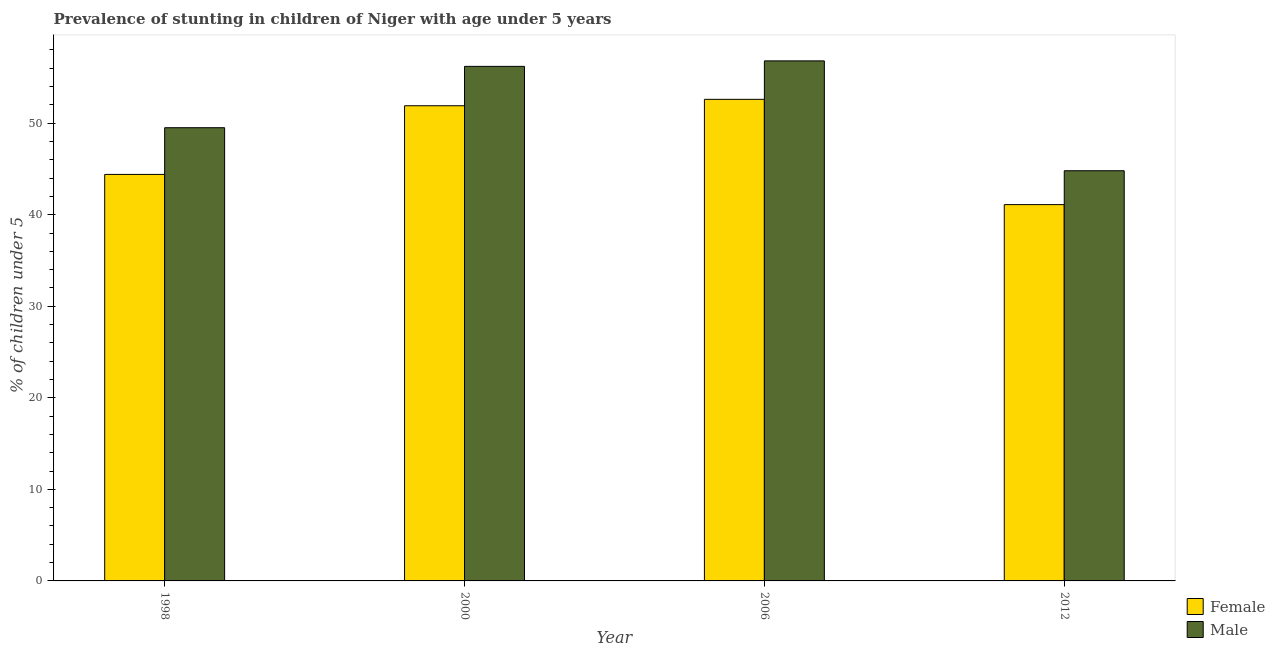How many different coloured bars are there?
Your response must be concise. 2. How many groups of bars are there?
Offer a very short reply. 4. How many bars are there on the 2nd tick from the left?
Your answer should be very brief. 2. What is the label of the 1st group of bars from the left?
Your response must be concise. 1998. What is the percentage of stunted female children in 2000?
Give a very brief answer. 51.9. Across all years, what is the maximum percentage of stunted female children?
Keep it short and to the point. 52.6. Across all years, what is the minimum percentage of stunted male children?
Your answer should be very brief. 44.8. In which year was the percentage of stunted male children maximum?
Your answer should be very brief. 2006. What is the total percentage of stunted female children in the graph?
Offer a very short reply. 190. What is the difference between the percentage of stunted male children in 2000 and that in 2012?
Provide a short and direct response. 11.4. What is the difference between the percentage of stunted female children in 2012 and the percentage of stunted male children in 1998?
Your answer should be compact. -3.3. What is the average percentage of stunted female children per year?
Your response must be concise. 47.5. In the year 2012, what is the difference between the percentage of stunted female children and percentage of stunted male children?
Offer a terse response. 0. What is the ratio of the percentage of stunted female children in 2006 to that in 2012?
Make the answer very short. 1.28. What is the difference between the highest and the second highest percentage of stunted female children?
Offer a very short reply. 0.7. Is the sum of the percentage of stunted male children in 2000 and 2006 greater than the maximum percentage of stunted female children across all years?
Make the answer very short. Yes. What does the 2nd bar from the left in 2000 represents?
Give a very brief answer. Male. What does the 2nd bar from the right in 2000 represents?
Your response must be concise. Female. How many bars are there?
Your response must be concise. 8. What is the difference between two consecutive major ticks on the Y-axis?
Provide a succinct answer. 10. Does the graph contain grids?
Give a very brief answer. No. Where does the legend appear in the graph?
Offer a very short reply. Bottom right. How many legend labels are there?
Provide a succinct answer. 2. What is the title of the graph?
Give a very brief answer. Prevalence of stunting in children of Niger with age under 5 years. What is the label or title of the Y-axis?
Your response must be concise.  % of children under 5. What is the  % of children under 5 in Female in 1998?
Provide a succinct answer. 44.4. What is the  % of children under 5 in Male in 1998?
Make the answer very short. 49.5. What is the  % of children under 5 in Female in 2000?
Provide a short and direct response. 51.9. What is the  % of children under 5 of Male in 2000?
Your answer should be compact. 56.2. What is the  % of children under 5 of Female in 2006?
Provide a succinct answer. 52.6. What is the  % of children under 5 in Male in 2006?
Keep it short and to the point. 56.8. What is the  % of children under 5 of Female in 2012?
Your response must be concise. 41.1. What is the  % of children under 5 in Male in 2012?
Offer a terse response. 44.8. Across all years, what is the maximum  % of children under 5 in Female?
Keep it short and to the point. 52.6. Across all years, what is the maximum  % of children under 5 in Male?
Your answer should be very brief. 56.8. Across all years, what is the minimum  % of children under 5 in Female?
Give a very brief answer. 41.1. Across all years, what is the minimum  % of children under 5 of Male?
Offer a very short reply. 44.8. What is the total  % of children under 5 of Female in the graph?
Provide a succinct answer. 190. What is the total  % of children under 5 in Male in the graph?
Provide a succinct answer. 207.3. What is the difference between the  % of children under 5 in Female in 1998 and that in 2006?
Ensure brevity in your answer.  -8.2. What is the difference between the  % of children under 5 in Male in 1998 and that in 2006?
Provide a short and direct response. -7.3. What is the difference between the  % of children under 5 of Male in 1998 and that in 2012?
Ensure brevity in your answer.  4.7. What is the difference between the  % of children under 5 of Male in 2000 and that in 2006?
Keep it short and to the point. -0.6. What is the difference between the  % of children under 5 in Female in 1998 and the  % of children under 5 in Male in 2006?
Give a very brief answer. -12.4. What is the difference between the  % of children under 5 of Female in 2000 and the  % of children under 5 of Male in 2012?
Offer a terse response. 7.1. What is the difference between the  % of children under 5 of Female in 2006 and the  % of children under 5 of Male in 2012?
Give a very brief answer. 7.8. What is the average  % of children under 5 in Female per year?
Your answer should be compact. 47.5. What is the average  % of children under 5 in Male per year?
Make the answer very short. 51.83. In the year 1998, what is the difference between the  % of children under 5 in Female and  % of children under 5 in Male?
Make the answer very short. -5.1. In the year 2000, what is the difference between the  % of children under 5 of Female and  % of children under 5 of Male?
Your answer should be very brief. -4.3. In the year 2006, what is the difference between the  % of children under 5 of Female and  % of children under 5 of Male?
Offer a terse response. -4.2. What is the ratio of the  % of children under 5 in Female in 1998 to that in 2000?
Offer a very short reply. 0.86. What is the ratio of the  % of children under 5 in Male in 1998 to that in 2000?
Provide a short and direct response. 0.88. What is the ratio of the  % of children under 5 of Female in 1998 to that in 2006?
Give a very brief answer. 0.84. What is the ratio of the  % of children under 5 of Male in 1998 to that in 2006?
Make the answer very short. 0.87. What is the ratio of the  % of children under 5 in Female in 1998 to that in 2012?
Make the answer very short. 1.08. What is the ratio of the  % of children under 5 of Male in 1998 to that in 2012?
Provide a short and direct response. 1.1. What is the ratio of the  % of children under 5 in Female in 2000 to that in 2006?
Your answer should be very brief. 0.99. What is the ratio of the  % of children under 5 in Male in 2000 to that in 2006?
Your response must be concise. 0.99. What is the ratio of the  % of children under 5 in Female in 2000 to that in 2012?
Make the answer very short. 1.26. What is the ratio of the  % of children under 5 of Male in 2000 to that in 2012?
Your response must be concise. 1.25. What is the ratio of the  % of children under 5 in Female in 2006 to that in 2012?
Give a very brief answer. 1.28. What is the ratio of the  % of children under 5 of Male in 2006 to that in 2012?
Offer a very short reply. 1.27. What is the difference between the highest and the second highest  % of children under 5 of Female?
Keep it short and to the point. 0.7. What is the difference between the highest and the lowest  % of children under 5 of Male?
Offer a very short reply. 12. 